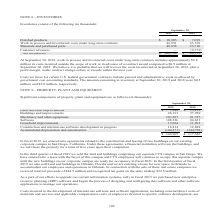According to Cubic's financial document, What do the costs incurred in the development of internal-use software and software applications include? external direct costs of materials and services and applicable compensation costs of employees devoted to specific software development. The document states: "use software and software applications, including external direct costs of materials and services and applicable compensation costs of employees devot..." Also, What is the amount that was capitalized in 2017 for qualifying software development costs as internal-use software development in progress? Based on the financial document, the answer is $16.7 million. Also, In which years were the incurred costs related to the purchase and development of the ERP system recorded? The document contains multiple relevant values: 2019, 2018, 2017. From the document: "September 30, 2019 2018 September 30, 2019 2018 September 30, 2019 2018 September 30, 2019 2018 September 30, 2019 2018 September 30, 2019 2018 Septem..." Additionally, In which year was the total amount of property, plant and equipment larger? According to the financial document, 2019. The relevant text states: "September 30, 2019 2018..." Also, can you calculate: What is the change in leasehold improvements from 2018 to 2019? Based on the calculation: 17,064-11,991, the result is 5073 (in thousands). This is based on the information: "Leasehold improvements 17,064 11,991 Construction and internal-use software development in progress 16,814 12,888 Leasehold improvements 17,064 11,991 Construction and internal-use software developmen..." The key data points involved are: 11,991, 17,064. Also, can you calculate: What is the percentage change in leasehold improvements from 2018 to 2019? To answer this question, I need to perform calculations using the financial data. The calculation is: (17,064-11,991)/11,991, which equals 42.31 (percentage). This is based on the information: "Leasehold improvements 17,064 11,991 Construction and internal-use software development in progress 16,814 12,888 Leasehold improvements 17,064 11,991 Construction and internal-use software developmen..." The key data points involved are: 11,991, 17,064. 